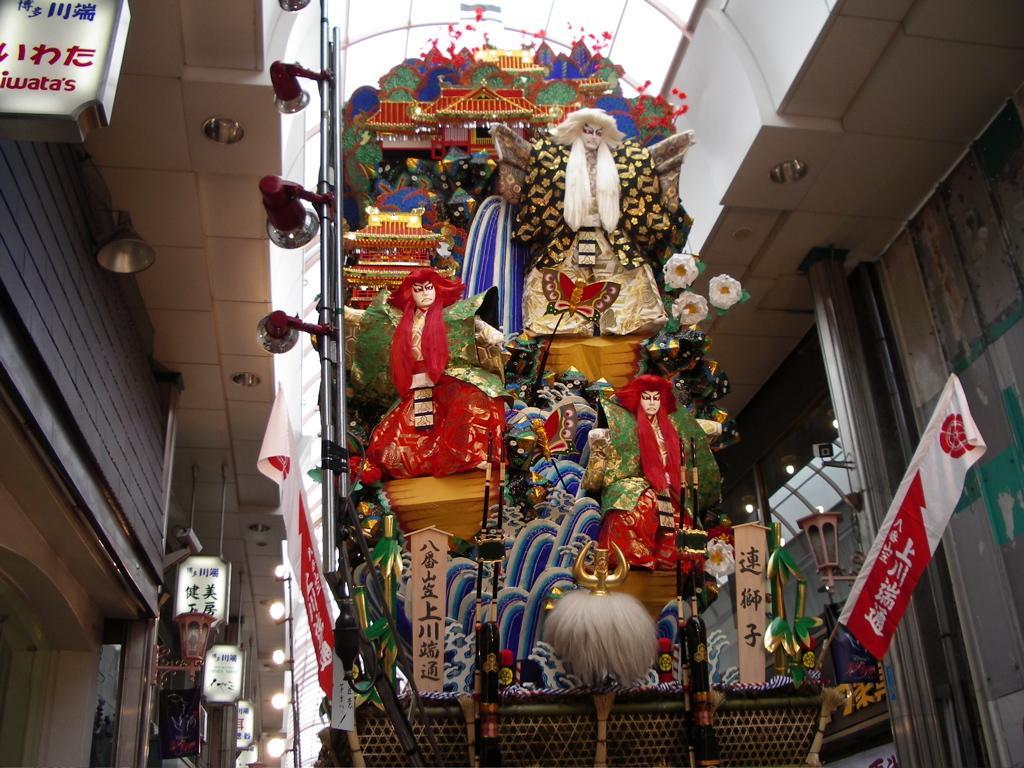Describe this image in one or two sentences. In this image in the center there are some items, flags and some lights, boards and some other objects. On the right side and left side there are some buildings, lights and some boards. 